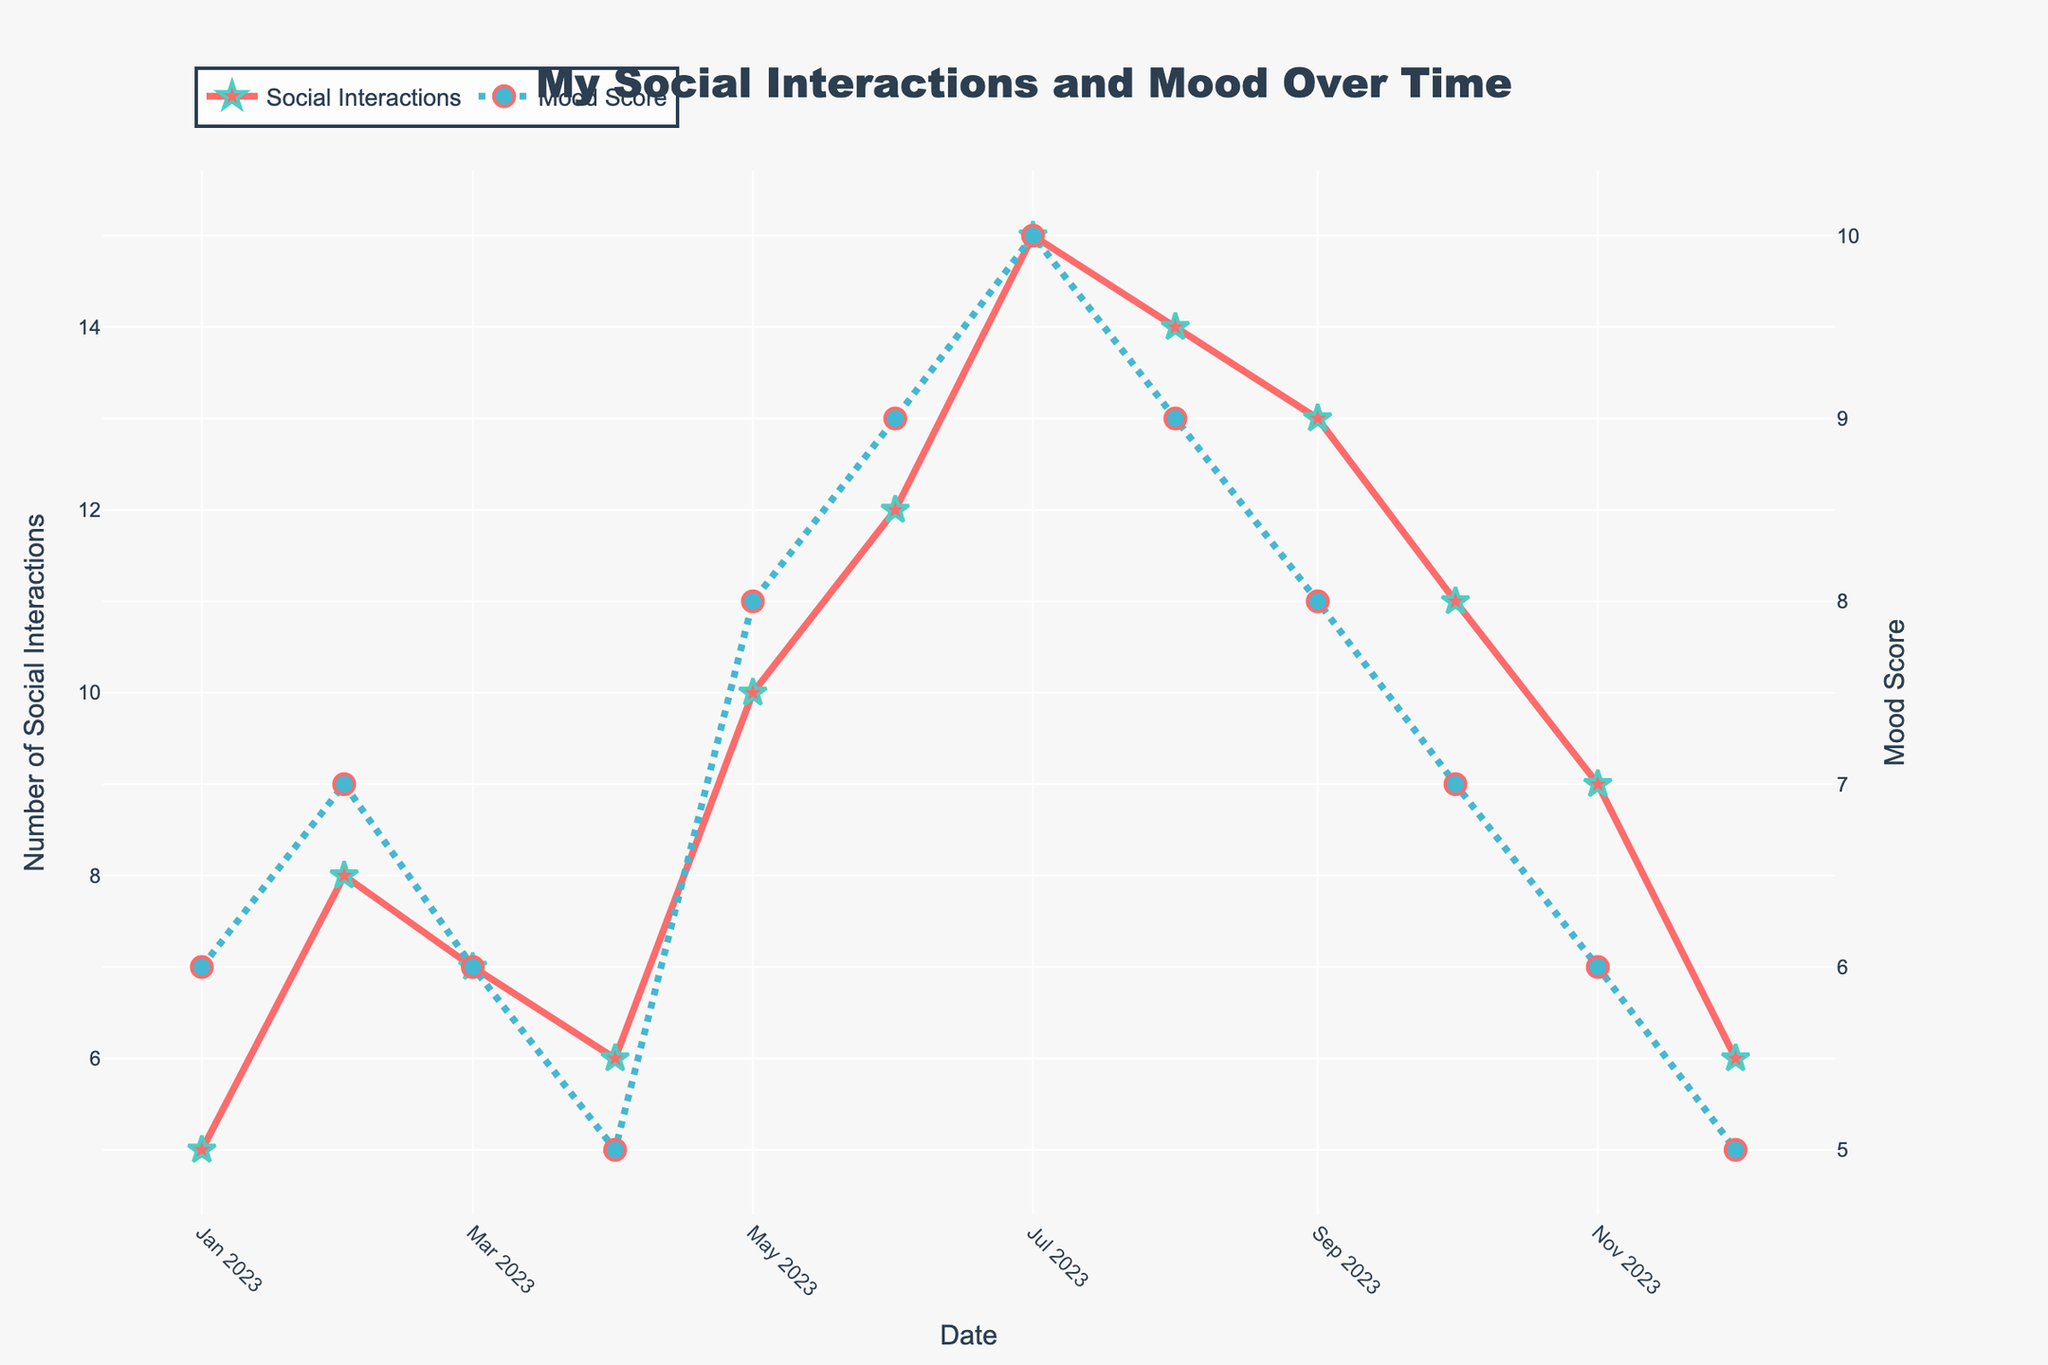What is the title of the figure? The figure's title is displayed prominently at the top center.
Answer: My Social Interactions and Mood Over Time How many data points are plotted for both social interactions and mood score? By looking at the markers on the plot, you can count that there are 12 data points for each series, one for each month of the year.
Answer: 12 What are the highest values of social interactions and mood score, and in which months do they occur? The highest value for social interactions is 15 in July, and the highest value for mood score is 10, also in July.
Answer: Social interactions: 15 (July), Mood Score: 10 (July) In which month do both social interactions and mood score reach their lowest values? By examining the plot, both social interactions and mood score reach their lowest values in December, with values of 6 and 5 respectively.
Answer: December How do social interactions and mood score change from January to July? From January to July, the plot shows an increasing trend in both social interactions and mood score. Social interactions rise from 5 to 15, and mood score rises from 6 to 10.
Answer: Both increase What is the general trend observed for mood score as the number of social interactions increases? Generally, as the number of social interactions increases, the mood score also tends to increase, showing a positive correlation.
Answer: Positive correlation Calculate the average social interactions and mood score over the year. Summing up the social interactions values (5+8+7+6+10+12+15+14+13+11+9+6) gives 116, and dividing by 12 gives approximately 9.67. Summing up the mood scores (6+7+6+5+8+9+10+9+8+7+6+5) gives 86, and dividing by 12 gives approximately 7.17.
Answer: Social interactions: 9.67, Mood Score: 7.17 Compare the mood score in June to the mood score in December. How much higher or lower is it? The mood score in June is 9, while in December it is 5. The mood score in June is 4 points higher than in December.
Answer: 4 points higher During which months does the number of social interactions decrease compared to the previous month? The number of social interactions decreases in April compared to March (from 7 to 6), in October compared to September (from 13 to 11), and in November compared to October (from 11 to 9).
Answer: April, October, November 